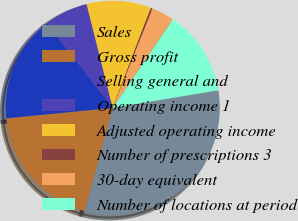Convert chart. <chart><loc_0><loc_0><loc_500><loc_500><pie_chart><fcel>Sales<fcel>Gross profit<fcel>Selling general and<fcel>Operating income 1<fcel>Adjusted operating income<fcel>Number of prescriptions 3<fcel>30-day equivalent<fcel>Number of locations at period<nl><fcel>31.85%<fcel>19.21%<fcel>16.05%<fcel>6.58%<fcel>9.74%<fcel>0.26%<fcel>3.42%<fcel>12.89%<nl></chart> 